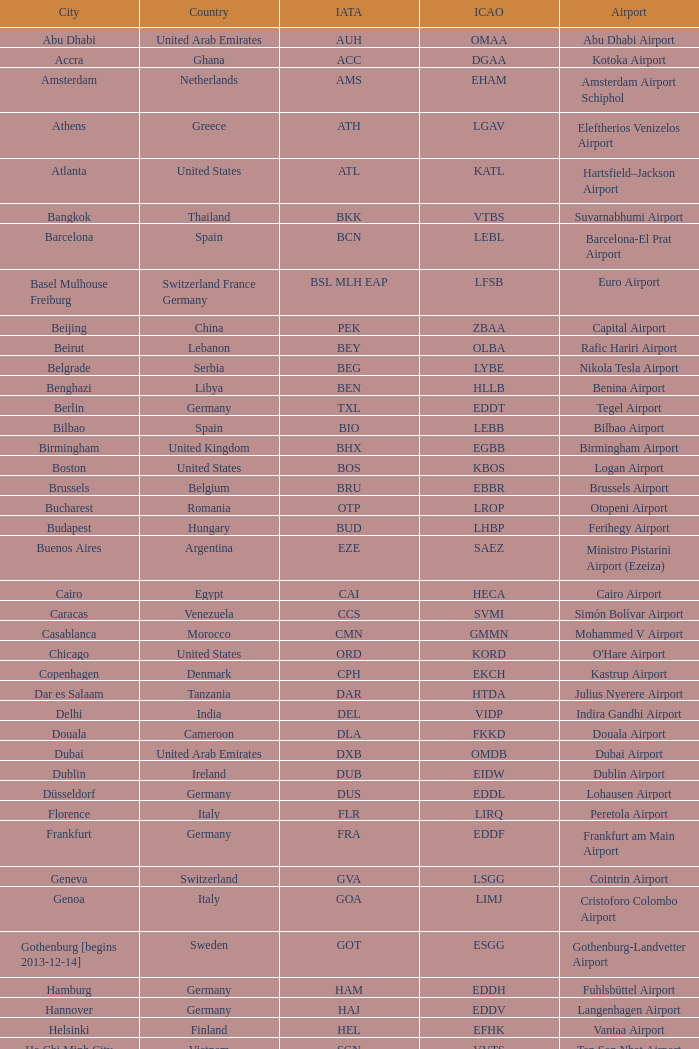What icao identifier corresponds to douala city? FKKD. 